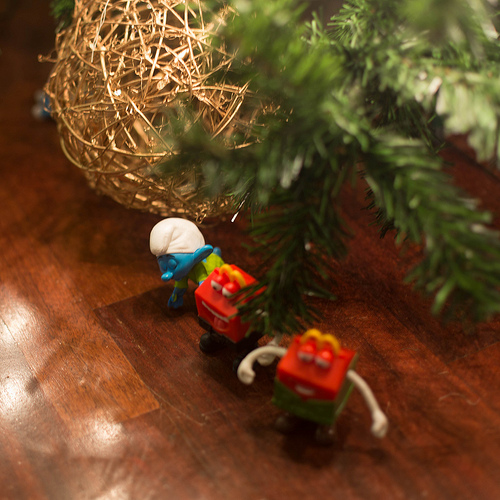<image>
Is there a smurf behind the tree? Yes. From this viewpoint, the smurf is positioned behind the tree, with the tree partially or fully occluding the smurf. 